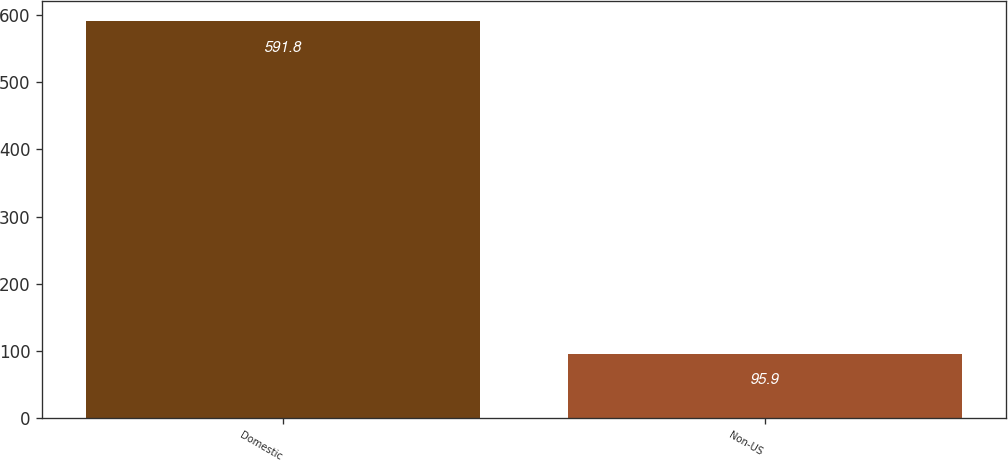<chart> <loc_0><loc_0><loc_500><loc_500><bar_chart><fcel>Domestic<fcel>Non-US<nl><fcel>591.8<fcel>95.9<nl></chart> 